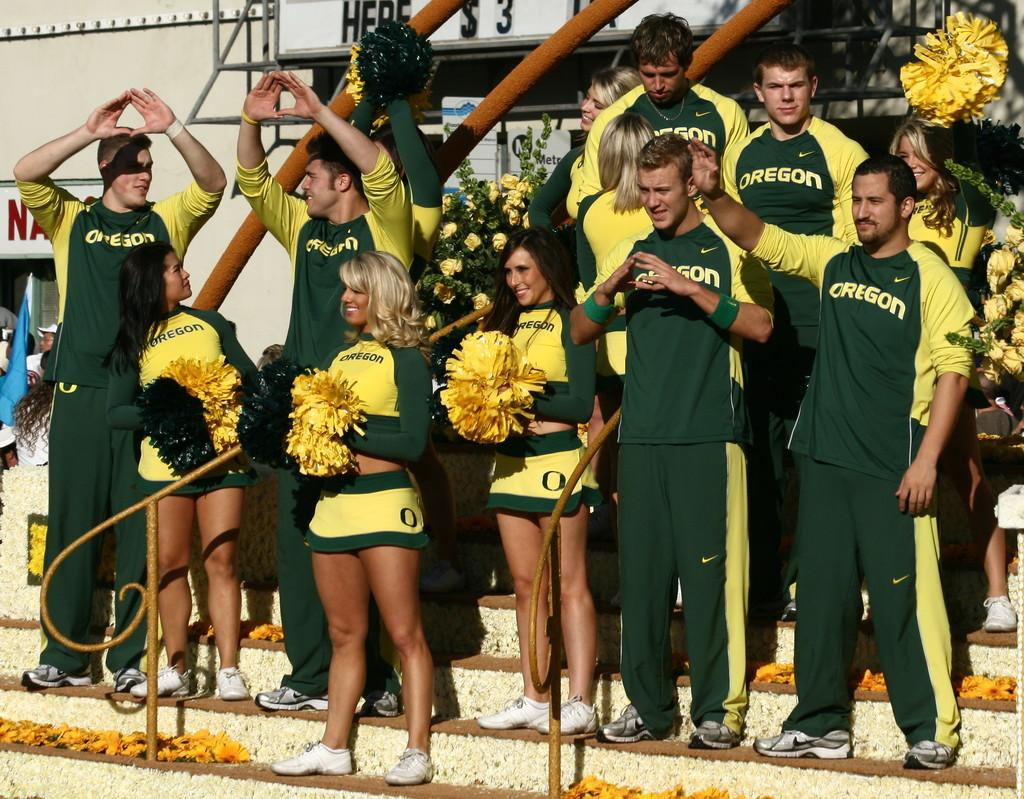<image>
Write a terse but informative summary of the picture. A group of young people wear uniforms with the name Oregon printed on the front. 